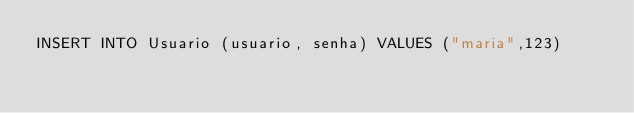Convert code to text. <code><loc_0><loc_0><loc_500><loc_500><_SQL_>INSERT INTO Usuario (usuario, senha) VALUES ("maria",123)
</code> 